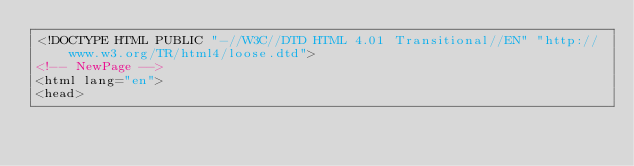Convert code to text. <code><loc_0><loc_0><loc_500><loc_500><_HTML_><!DOCTYPE HTML PUBLIC "-//W3C//DTD HTML 4.01 Transitional//EN" "http://www.w3.org/TR/html4/loose.dtd">
<!-- NewPage -->
<html lang="en">
<head></code> 